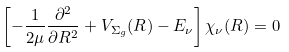Convert formula to latex. <formula><loc_0><loc_0><loc_500><loc_500>\left [ - \frac { 1 } { 2 \mu } \frac { \partial ^ { 2 } } { \partial R ^ { 2 } } + V _ { \Sigma _ { g } } ( R ) - E _ { \nu } \right ] \chi _ { \nu } ( R ) = 0</formula> 